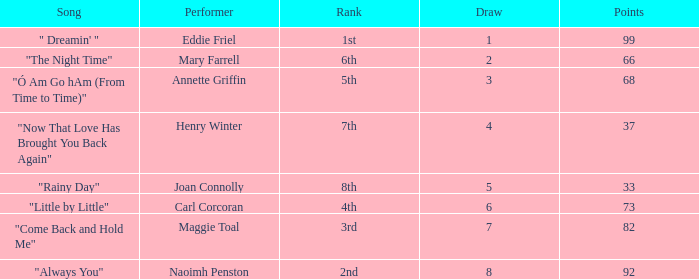Would you be able to parse every entry in this table? {'header': ['Song', 'Performer', 'Rank', 'Draw', 'Points'], 'rows': [['" Dreamin\' "', 'Eddie Friel', '1st', '1', '99'], ['"The Night Time"', 'Mary Farrell', '6th', '2', '66'], ['"Ó Am Go hAm (From Time to Time)"', 'Annette Griffin', '5th', '3', '68'], ['"Now That Love Has Brought You Back Again"', 'Henry Winter', '7th', '4', '37'], ['"Rainy Day"', 'Joan Connolly', '8th', '5', '33'], ['"Little by Little"', 'Carl Corcoran', '4th', '6', '73'], ['"Come Back and Hold Me"', 'Maggie Toal', '3rd', '7', '82'], ['"Always You"', 'Naoimh Penston', '2nd', '8', '92']]} What is the average number of points when the ranking is 7th and the draw is less than 4? None. 